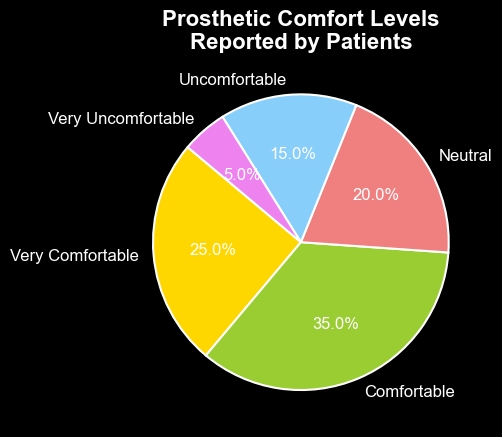What percentage of patients reported being very comfortable or comfortable with their prosthetics? To determine the combined percentage for 'Very Comfortable' and 'Comfortable', add the two percentages together: 25% (Very Comfortable) + 35% (Comfortable) = 60%
Answer: 60% What is the difference between the percentage of patients who reported being comfortable and those who reported being very uncomfortable? Subtract the percentage of 'Very Uncomfortable' from 'Comfortable': 35% (Comfortable) - 5% (Very Uncomfortable) = 30%
Answer: 30% Which comfort level was reported by the smallest percentage of patients? From the pie chart, we can see that 'Very Uncomfortable' has the smallest slice, indicating the lowest percentage: 5%
Answer: Very Uncomfortable Are there more patients who are neutral about their prosthetic comfort or those who are uncomfortable? Compare the percentages of 'Neutral' and 'Uncomfortable': 20% (Neutral) > 15% (Uncomfortable)
Answer: Neutral What percentage of patients reported experiencing discomfort (either uncomfortable or very uncomfortable)? Add the percentages of 'Uncomfortable' and 'Very Uncomfortable': 15% (Uncomfortable) + 5% (Very Uncomfortable) = 20%
Answer: 20% Which comfort level has the largest percentage, and what is that percentage? From the pie chart, we see 'Comfortable' has the largest slice which is 35%
Answer: Comfortable, 35% If you sum the percentages of patients who are Neutral, Uncomfortable, or Very Uncomfortable, what is the total? Add the percentages: 20% (Neutral) + 15% (Uncomfortable) + 5% (Very Uncomfortable) = 40%
Answer: 40% Which slice of the pie chart is represented in light coral color? The light coral color corresponds to the 'Neutral' category, as indicated in the pie chart's color scheme
Answer: Neutral 